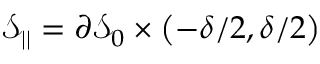<formula> <loc_0><loc_0><loc_500><loc_500>\mathcal { S } _ { | | } = \partial \mathcal { S } _ { 0 } \times \left ( - \delta / 2 , \delta / 2 \right )</formula> 